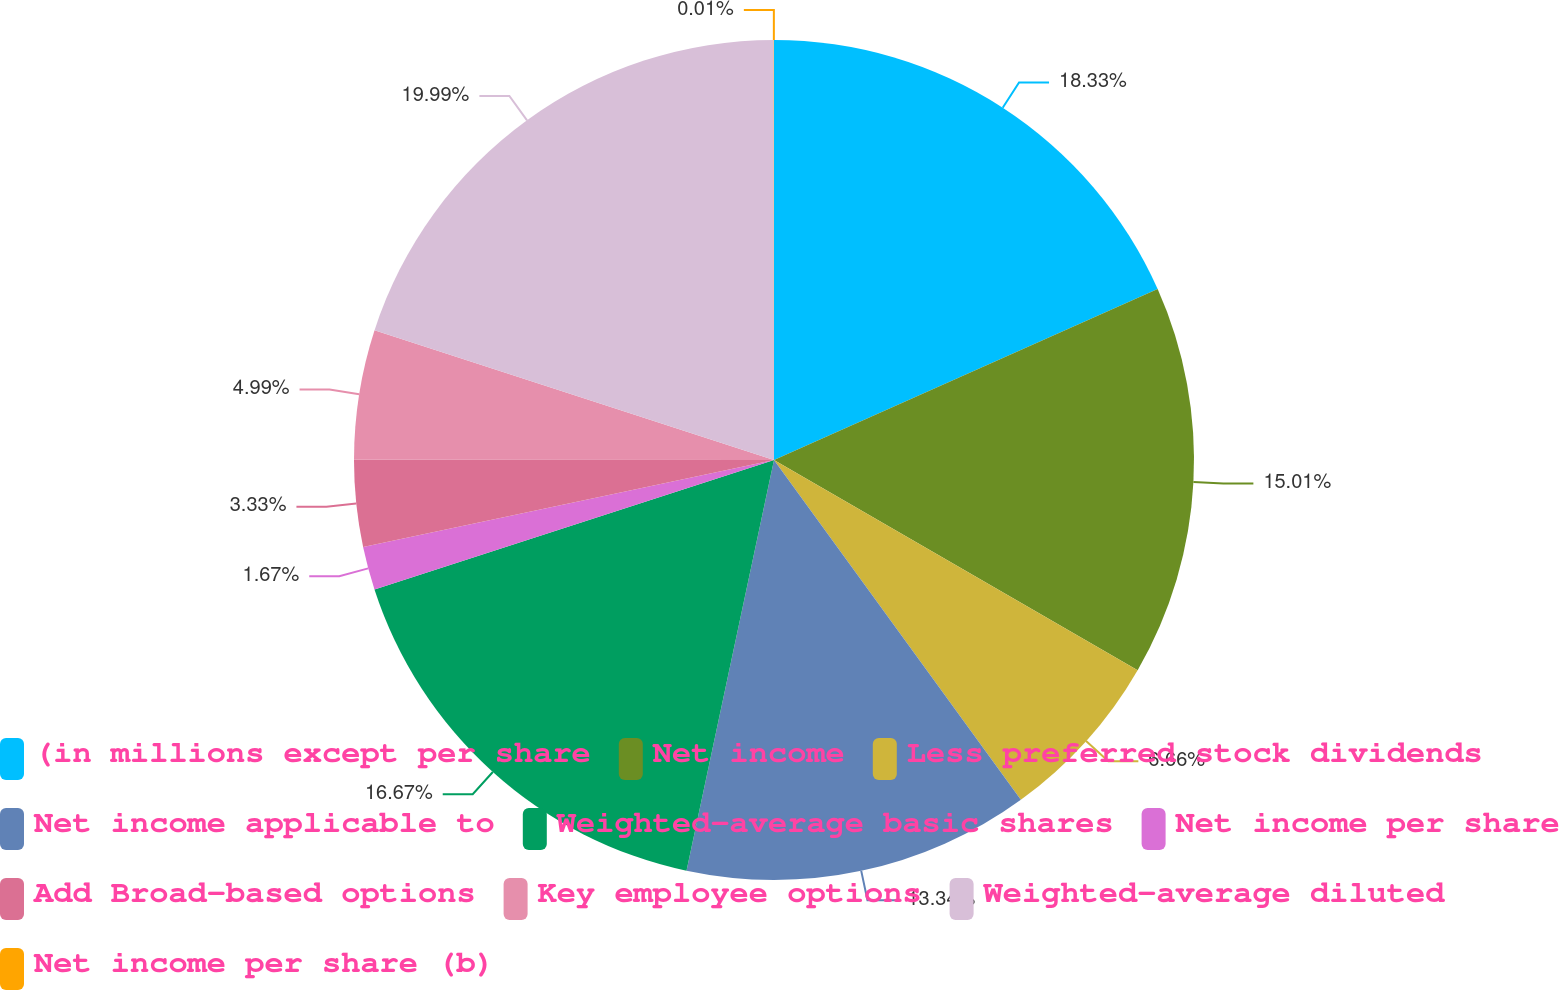<chart> <loc_0><loc_0><loc_500><loc_500><pie_chart><fcel>(in millions except per share<fcel>Net income<fcel>Less preferred stock dividends<fcel>Net income applicable to<fcel>Weighted-average basic shares<fcel>Net income per share<fcel>Add Broad-based options<fcel>Key employee options<fcel>Weighted-average diluted<fcel>Net income per share (b)<nl><fcel>18.33%<fcel>15.01%<fcel>6.66%<fcel>13.34%<fcel>16.67%<fcel>1.67%<fcel>3.33%<fcel>4.99%<fcel>19.99%<fcel>0.01%<nl></chart> 